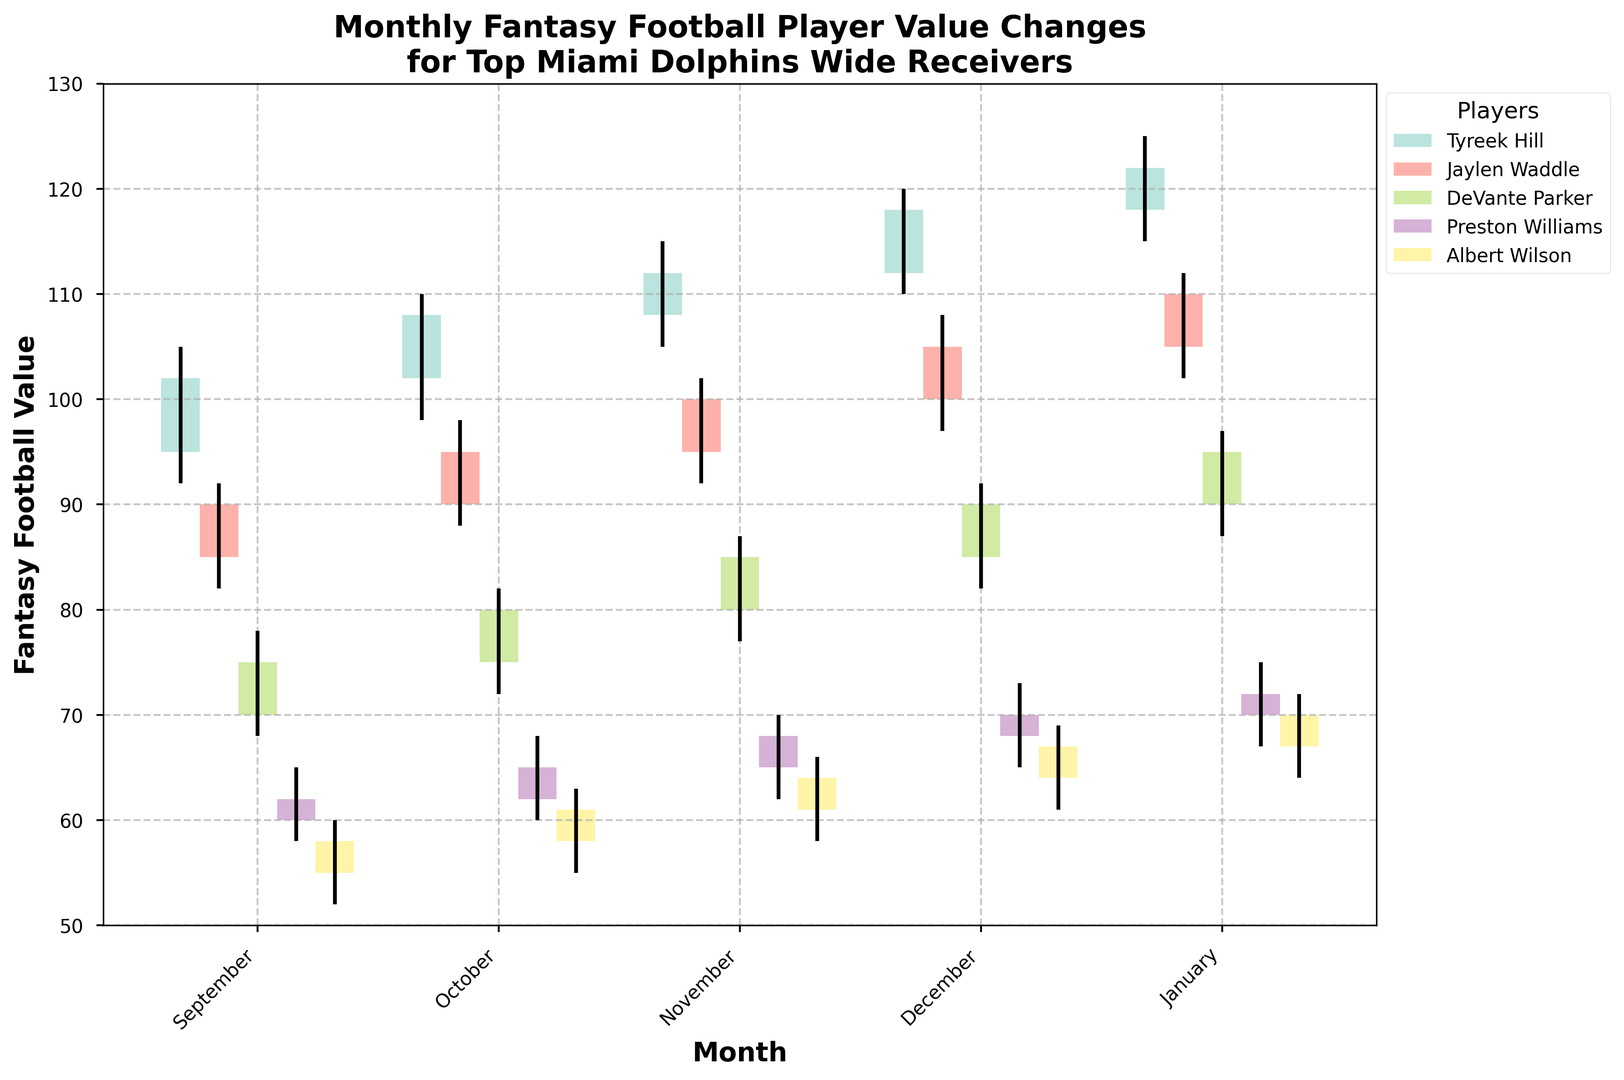What is the highest fantasy football value achieved by Tyreek Hill? Look at the candlestick bars for Tyreek Hill across all months and identify the maximum value achieved within any month.
Answer: 125 Which player had the highest closing value in October? Look at the closing values for each player in October and identify the highest one. Tyreek Hill's closing value in October is 108, which is higher than the others.
Answer: Tyreek Hill Compare DeVante Parker's and Jaylen Waddle's opening values in November. Which one is higher? Look at the opening values for both players in November. DeVante Parker's opening value in November is 80, while Jaylen Waddle's is 95.
Answer: Jaylen Waddle What is the average closing value for Jaylen Waddle from October to December? Sum the closing values of Jaylen Waddle for October, November, and December, then divide by the number of months. (95 + 100 + 105) / 3 = 300 / 3 = 100
Answer: 100 Which player had the smallest range in fantasy football value in December? Calculate the range (high - low) for each player in December and identify the smallest one. Tyreek Hill: 120-110 = 10, Jaylen Waddle: 108-97 = 11, DeVante Parker: 92-82 = 10, Preston Williams: 73-65 = 8, Albert Wilson: 69-61 = 8. Both Preston Williams and Albert Wilson have the smallest range (8).
Answer: Preston Williams or Albert Wilson Who showed the most consistent increase in closing value across all months? Look for the player with increasing closing values from September to January without any decreases. Tyreek Hill's values are continuously increasing (102, 108, 112, 118, 122).
Answer: Tyreek Hill What was the difference between Tyreek Hill's opening and closing values in January? Subtract the opening value of Tyreek Hill in January from his closing value in January. 122 - 118 = 4
Answer: 4 Which month saw the highest high value for any player? Identify the month and player. Look at the highest "High" value across all months for all players. January has the highest value of 125 by Tyreek Hill.
Answer: January, Tyreek Hill 